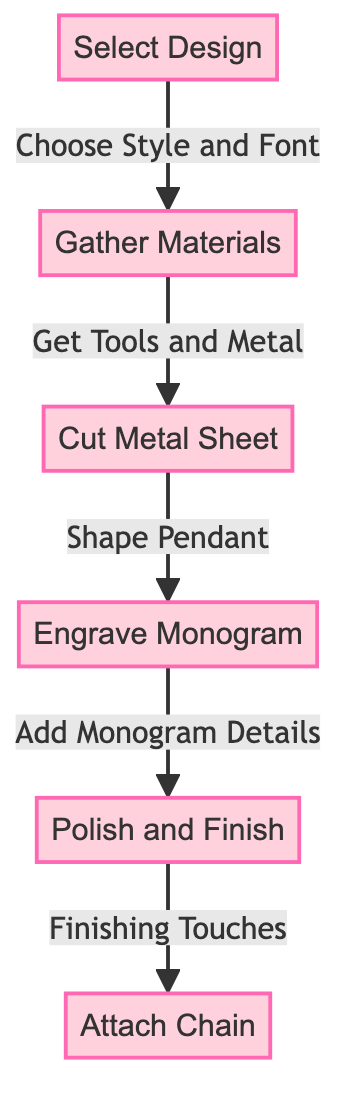What is the last step in crafting a custom monogram necklace? The last step in the diagram is to "Attach Chain," which is the final action taken after preparing the pendant.
Answer: Attach Chain How many main steps are involved in the process? There are six main steps depicted in the flowchart, outlining the progression from selecting a design to attaching the chain.
Answer: Six What type of node comes directly after "Engrave Monogram"? The node that follows "Engrave Monogram" is "Add Monogram Details," indicating what needs to be done next in the sequence.
Answer: Add Monogram Details What relationship exists between "Gather Materials" and "Cut Metal Sheet"? "Gather Materials" is directly sequenced to "Cut Metal Sheet," indicating that gathering materials is a prerequisite step before cutting the metal.
Answer: Prerequisite Which action occurs immediately before "Polish and Finish"? The action that takes place immediately before "Polish and Finish" is "Add Monogram Details," indicating the necessary step prior to finishing touches.
Answer: Add Monogram Details How are the steps in the diagram connected? The steps are connected by arrows, showing the directional flow from one action to the next in the necklace crafting process.
Answer: Arrows What must you select first in the necklace crafting process? The first action to select is "Select Design," starting point of the process according to the flowchart.
Answer: Select Design Which material-related step comes third in the process? The third step in the flowchart is "Cut Metal Sheet," relating to the material transition after gathering materials.
Answer: Cut Metal Sheet 